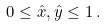<formula> <loc_0><loc_0><loc_500><loc_500>0 \leq \hat { x } , \hat { y } \leq 1 \, .</formula> 